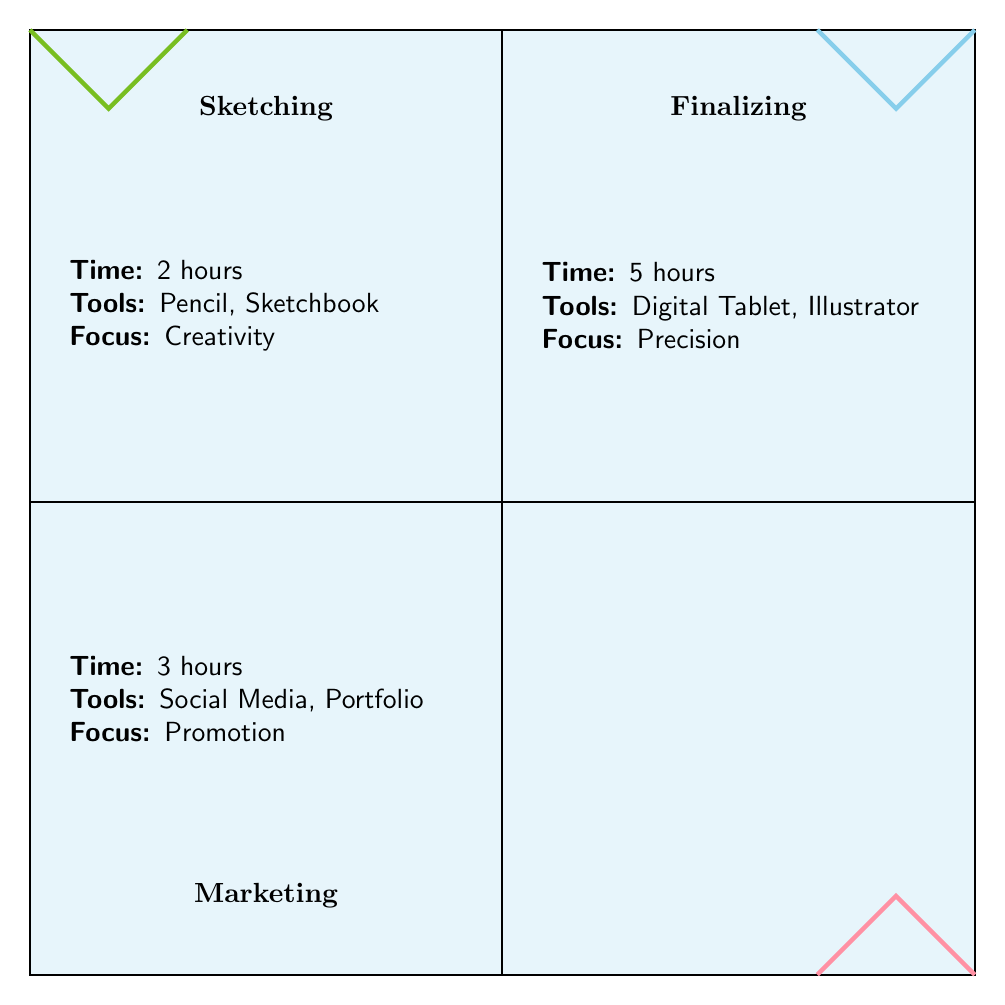What is the time spent on sketching? The diagram states that the time spent on sketching is provided in the appropriate quadrant. We can see labeled data that directly indicates "2 hours" in the sketching section.
Answer: 2 hours What tools are used in the finalizing stage? The finalizing section lists "Digital Tablet, Stylus, Adobe Illustrator" under the tools used. This can be easily found by referring to that quadrant.
Answer: Digital Tablet, Stylus, Adobe Illustrator How much time does marketing take compared to sketching? To find the answer, we compare the time spent in both quadrants. Marketing takes "3 hours" and sketching takes "2 hours." Therefore, marketing takes 1 hour more than sketching.
Answer: 1 hour more Which stage focuses on creativity? By evaluating the key focus points listed in the quadrants, we can clearly see that the sketching stage has "Creativity" as its main focus.
Answer: Creativity What activities are included in the finalizing stage? The finalizing quadrant specifies the activities involved, which are listed as "Detailing, Coloring, Refinement." These activities give insight into what happens during this stage.
Answer: Detailing, Coloring, Refinement How many total tools are mentioned across all stages? We need to count the unique tools in each quadrant: Sketching lists 3 tools, Finalizing lists 3 tools, and Marketing lists 3 tools. Summing these gives a total of 9 tools.
Answer: 9 tools What is the primary focus of the marketing stage? The marketing quadrant highlights "Promotion" as its key focus. This is a direct piece of information glanceable from the diagram.
Answer: Promotion Is the time spent on finalizing greater than the total time for sketching and marketing combined? First, we add the time for sketching (2 hours) and marketing (3 hours), which totals 5 hours. The time for finalizing is 5 hours. Hence, finalizing is equal to the combined time, not greater.
Answer: No 